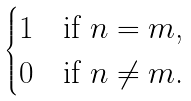Convert formula to latex. <formula><loc_0><loc_0><loc_500><loc_500>\begin{cases} 1 & \text {if $n=m$,} \\ 0 & \text {if $n \neq m$.} \end{cases}</formula> 